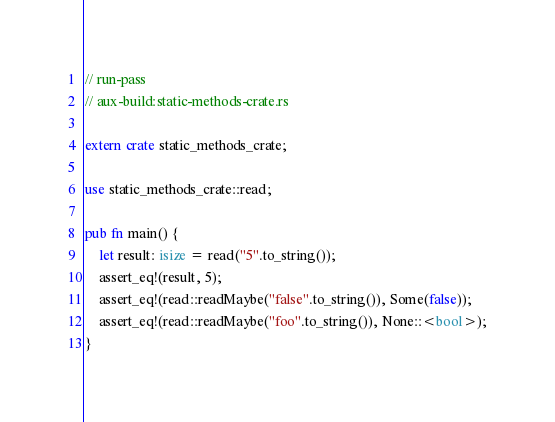<code> <loc_0><loc_0><loc_500><loc_500><_Rust_>// run-pass
// aux-build:static-methods-crate.rs

extern crate static_methods_crate;

use static_methods_crate::read;

pub fn main() {
    let result: isize = read("5".to_string());
    assert_eq!(result, 5);
    assert_eq!(read::readMaybe("false".to_string()), Some(false));
    assert_eq!(read::readMaybe("foo".to_string()), None::<bool>);
}
</code> 